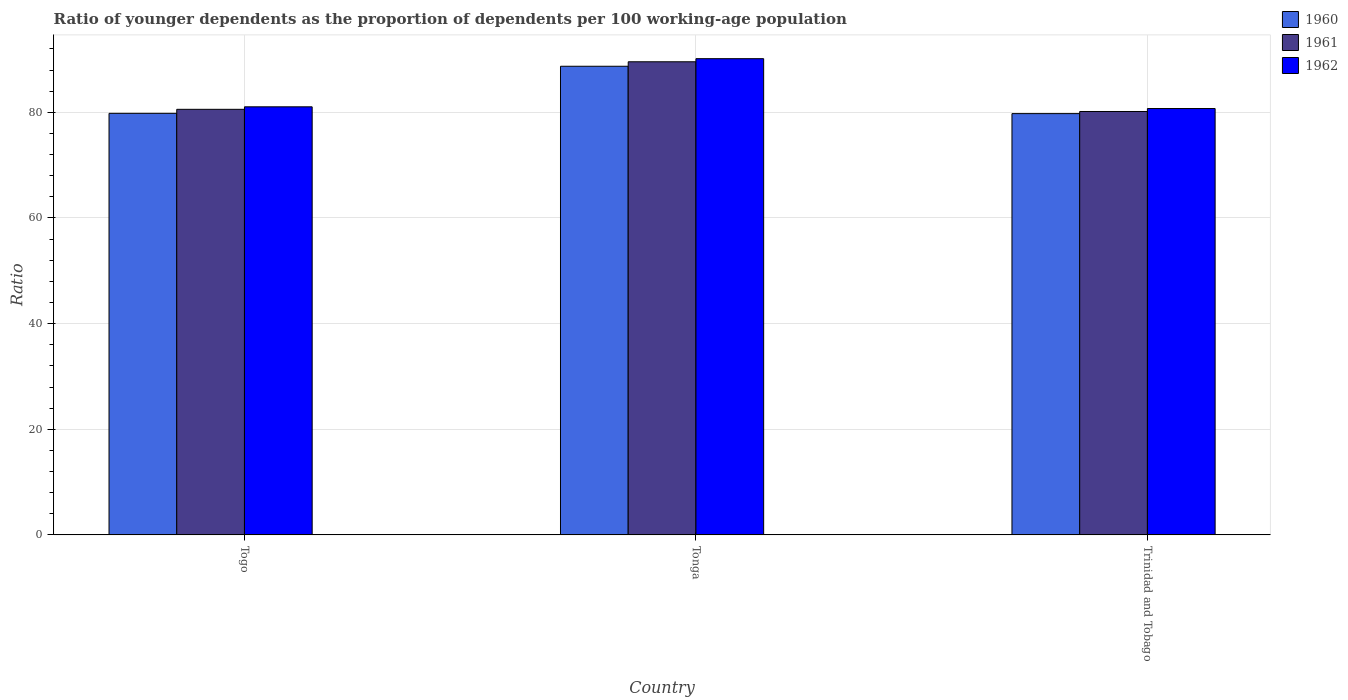How many groups of bars are there?
Provide a succinct answer. 3. Are the number of bars per tick equal to the number of legend labels?
Your response must be concise. Yes. How many bars are there on the 3rd tick from the right?
Offer a terse response. 3. What is the label of the 1st group of bars from the left?
Keep it short and to the point. Togo. What is the age dependency ratio(young) in 1962 in Trinidad and Tobago?
Keep it short and to the point. 80.72. Across all countries, what is the maximum age dependency ratio(young) in 1961?
Your answer should be very brief. 89.57. Across all countries, what is the minimum age dependency ratio(young) in 1962?
Provide a succinct answer. 80.72. In which country was the age dependency ratio(young) in 1962 maximum?
Provide a succinct answer. Tonga. In which country was the age dependency ratio(young) in 1962 minimum?
Your response must be concise. Trinidad and Tobago. What is the total age dependency ratio(young) in 1962 in the graph?
Your answer should be compact. 251.93. What is the difference between the age dependency ratio(young) in 1962 in Tonga and that in Trinidad and Tobago?
Your answer should be compact. 9.44. What is the difference between the age dependency ratio(young) in 1960 in Trinidad and Tobago and the age dependency ratio(young) in 1961 in Tonga?
Ensure brevity in your answer.  -9.82. What is the average age dependency ratio(young) in 1961 per country?
Provide a succinct answer. 83.44. What is the difference between the age dependency ratio(young) of/in 1962 and age dependency ratio(young) of/in 1960 in Trinidad and Tobago?
Your response must be concise. 0.96. In how many countries, is the age dependency ratio(young) in 1961 greater than 88?
Provide a short and direct response. 1. What is the ratio of the age dependency ratio(young) in 1961 in Tonga to that in Trinidad and Tobago?
Your response must be concise. 1.12. What is the difference between the highest and the second highest age dependency ratio(young) in 1961?
Offer a terse response. -9. What is the difference between the highest and the lowest age dependency ratio(young) in 1960?
Your response must be concise. 8.97. Is the sum of the age dependency ratio(young) in 1961 in Togo and Trinidad and Tobago greater than the maximum age dependency ratio(young) in 1962 across all countries?
Offer a very short reply. Yes. Is it the case that in every country, the sum of the age dependency ratio(young) in 1960 and age dependency ratio(young) in 1962 is greater than the age dependency ratio(young) in 1961?
Give a very brief answer. Yes. Are all the bars in the graph horizontal?
Offer a terse response. No. Are the values on the major ticks of Y-axis written in scientific E-notation?
Your response must be concise. No. How many legend labels are there?
Make the answer very short. 3. How are the legend labels stacked?
Provide a succinct answer. Vertical. What is the title of the graph?
Your answer should be compact. Ratio of younger dependents as the proportion of dependents per 100 working-age population. Does "2005" appear as one of the legend labels in the graph?
Your answer should be compact. No. What is the label or title of the X-axis?
Keep it short and to the point. Country. What is the label or title of the Y-axis?
Ensure brevity in your answer.  Ratio. What is the Ratio of 1960 in Togo?
Provide a succinct answer. 79.81. What is the Ratio of 1961 in Togo?
Keep it short and to the point. 80.57. What is the Ratio of 1962 in Togo?
Provide a succinct answer. 81.05. What is the Ratio of 1960 in Tonga?
Your answer should be compact. 88.73. What is the Ratio in 1961 in Tonga?
Your answer should be very brief. 89.57. What is the Ratio in 1962 in Tonga?
Give a very brief answer. 90.16. What is the Ratio in 1960 in Trinidad and Tobago?
Your response must be concise. 79.76. What is the Ratio in 1961 in Trinidad and Tobago?
Provide a succinct answer. 80.16. What is the Ratio of 1962 in Trinidad and Tobago?
Give a very brief answer. 80.72. Across all countries, what is the maximum Ratio in 1960?
Your answer should be compact. 88.73. Across all countries, what is the maximum Ratio of 1961?
Your answer should be very brief. 89.57. Across all countries, what is the maximum Ratio in 1962?
Make the answer very short. 90.16. Across all countries, what is the minimum Ratio of 1960?
Keep it short and to the point. 79.76. Across all countries, what is the minimum Ratio of 1961?
Offer a very short reply. 80.16. Across all countries, what is the minimum Ratio of 1962?
Provide a succinct answer. 80.72. What is the total Ratio of 1960 in the graph?
Make the answer very short. 248.3. What is the total Ratio of 1961 in the graph?
Provide a short and direct response. 250.31. What is the total Ratio of 1962 in the graph?
Provide a succinct answer. 251.93. What is the difference between the Ratio of 1960 in Togo and that in Tonga?
Your answer should be compact. -8.91. What is the difference between the Ratio of 1961 in Togo and that in Tonga?
Your answer should be very brief. -9. What is the difference between the Ratio in 1962 in Togo and that in Tonga?
Ensure brevity in your answer.  -9.11. What is the difference between the Ratio in 1960 in Togo and that in Trinidad and Tobago?
Offer a terse response. 0.05. What is the difference between the Ratio of 1961 in Togo and that in Trinidad and Tobago?
Keep it short and to the point. 0.41. What is the difference between the Ratio of 1962 in Togo and that in Trinidad and Tobago?
Provide a succinct answer. 0.33. What is the difference between the Ratio of 1960 in Tonga and that in Trinidad and Tobago?
Keep it short and to the point. 8.97. What is the difference between the Ratio in 1961 in Tonga and that in Trinidad and Tobago?
Keep it short and to the point. 9.41. What is the difference between the Ratio of 1962 in Tonga and that in Trinidad and Tobago?
Keep it short and to the point. 9.44. What is the difference between the Ratio of 1960 in Togo and the Ratio of 1961 in Tonga?
Provide a short and direct response. -9.76. What is the difference between the Ratio in 1960 in Togo and the Ratio in 1962 in Tonga?
Your answer should be compact. -10.35. What is the difference between the Ratio of 1961 in Togo and the Ratio of 1962 in Tonga?
Ensure brevity in your answer.  -9.59. What is the difference between the Ratio of 1960 in Togo and the Ratio of 1961 in Trinidad and Tobago?
Offer a very short reply. -0.35. What is the difference between the Ratio in 1960 in Togo and the Ratio in 1962 in Trinidad and Tobago?
Keep it short and to the point. -0.91. What is the difference between the Ratio of 1961 in Togo and the Ratio of 1962 in Trinidad and Tobago?
Keep it short and to the point. -0.15. What is the difference between the Ratio of 1960 in Tonga and the Ratio of 1961 in Trinidad and Tobago?
Your answer should be very brief. 8.56. What is the difference between the Ratio in 1960 in Tonga and the Ratio in 1962 in Trinidad and Tobago?
Your response must be concise. 8. What is the difference between the Ratio of 1961 in Tonga and the Ratio of 1962 in Trinidad and Tobago?
Offer a terse response. 8.85. What is the average Ratio in 1960 per country?
Your response must be concise. 82.77. What is the average Ratio of 1961 per country?
Offer a terse response. 83.44. What is the average Ratio in 1962 per country?
Provide a succinct answer. 83.98. What is the difference between the Ratio in 1960 and Ratio in 1961 in Togo?
Give a very brief answer. -0.76. What is the difference between the Ratio in 1960 and Ratio in 1962 in Togo?
Ensure brevity in your answer.  -1.24. What is the difference between the Ratio in 1961 and Ratio in 1962 in Togo?
Provide a succinct answer. -0.47. What is the difference between the Ratio in 1960 and Ratio in 1961 in Tonga?
Keep it short and to the point. -0.85. What is the difference between the Ratio in 1960 and Ratio in 1962 in Tonga?
Your response must be concise. -1.43. What is the difference between the Ratio in 1961 and Ratio in 1962 in Tonga?
Make the answer very short. -0.58. What is the difference between the Ratio of 1960 and Ratio of 1961 in Trinidad and Tobago?
Your answer should be very brief. -0.4. What is the difference between the Ratio of 1960 and Ratio of 1962 in Trinidad and Tobago?
Offer a terse response. -0.96. What is the difference between the Ratio of 1961 and Ratio of 1962 in Trinidad and Tobago?
Give a very brief answer. -0.56. What is the ratio of the Ratio in 1960 in Togo to that in Tonga?
Your answer should be compact. 0.9. What is the ratio of the Ratio in 1961 in Togo to that in Tonga?
Provide a succinct answer. 0.9. What is the ratio of the Ratio in 1962 in Togo to that in Tonga?
Your answer should be very brief. 0.9. What is the ratio of the Ratio in 1961 in Togo to that in Trinidad and Tobago?
Keep it short and to the point. 1.01. What is the ratio of the Ratio in 1962 in Togo to that in Trinidad and Tobago?
Your answer should be very brief. 1. What is the ratio of the Ratio in 1960 in Tonga to that in Trinidad and Tobago?
Offer a very short reply. 1.11. What is the ratio of the Ratio in 1961 in Tonga to that in Trinidad and Tobago?
Give a very brief answer. 1.12. What is the ratio of the Ratio of 1962 in Tonga to that in Trinidad and Tobago?
Provide a short and direct response. 1.12. What is the difference between the highest and the second highest Ratio in 1960?
Make the answer very short. 8.91. What is the difference between the highest and the second highest Ratio of 1961?
Offer a terse response. 9. What is the difference between the highest and the second highest Ratio in 1962?
Provide a short and direct response. 9.11. What is the difference between the highest and the lowest Ratio of 1960?
Your response must be concise. 8.97. What is the difference between the highest and the lowest Ratio in 1961?
Your answer should be compact. 9.41. What is the difference between the highest and the lowest Ratio of 1962?
Your answer should be compact. 9.44. 